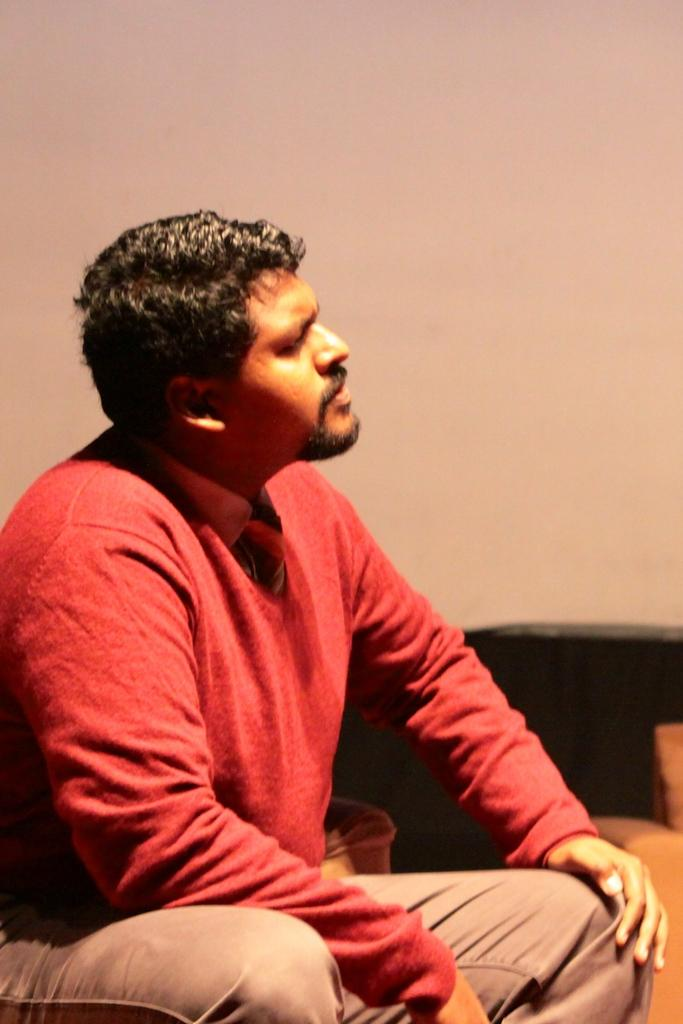Who is in the image? There is a man in the image. What is the man wearing? The man is wearing a red shirt. What is the man doing in the image? The man is sitting on a chair. What can be seen on the right side of the image? There is a couch on the right side of the image. What is visible in the background of the image? There is a wall in the background of the image. What type of government is depicted in the image? There is no depiction of a government in the image; it features a man sitting on a chair wearing a red shirt. 